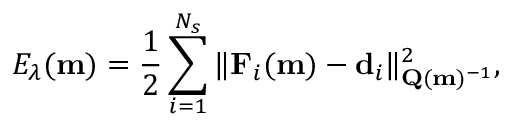Convert formula to latex. <formula><loc_0><loc_0><loc_500><loc_500>E _ { \lambda } ( m ) = \frac { 1 } { 2 } \sum _ { i = 1 } ^ { N _ { s } } \| F _ { i } ( m ) - d _ { i } \| _ { Q ( m ) ^ { - 1 } } ^ { 2 } ,</formula> 